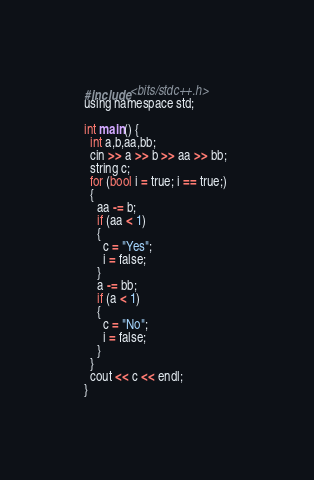Convert code to text. <code><loc_0><loc_0><loc_500><loc_500><_C_>#include <bits/stdc++.h>
using namespace std;

int main() {
  int a,b,aa,bb;
  cin >> a >> b >> aa >> bb;
  string c;
  for (bool i = true; i == true;) 
  {
    aa -= b;
    if (aa < 1)
    {
      c = "Yes";
      i = false;
    }
    a -= bb;
    if (a < 1)
    {
      c = "No";
      i = false;
    } 
  }
  cout << c << endl;
}</code> 